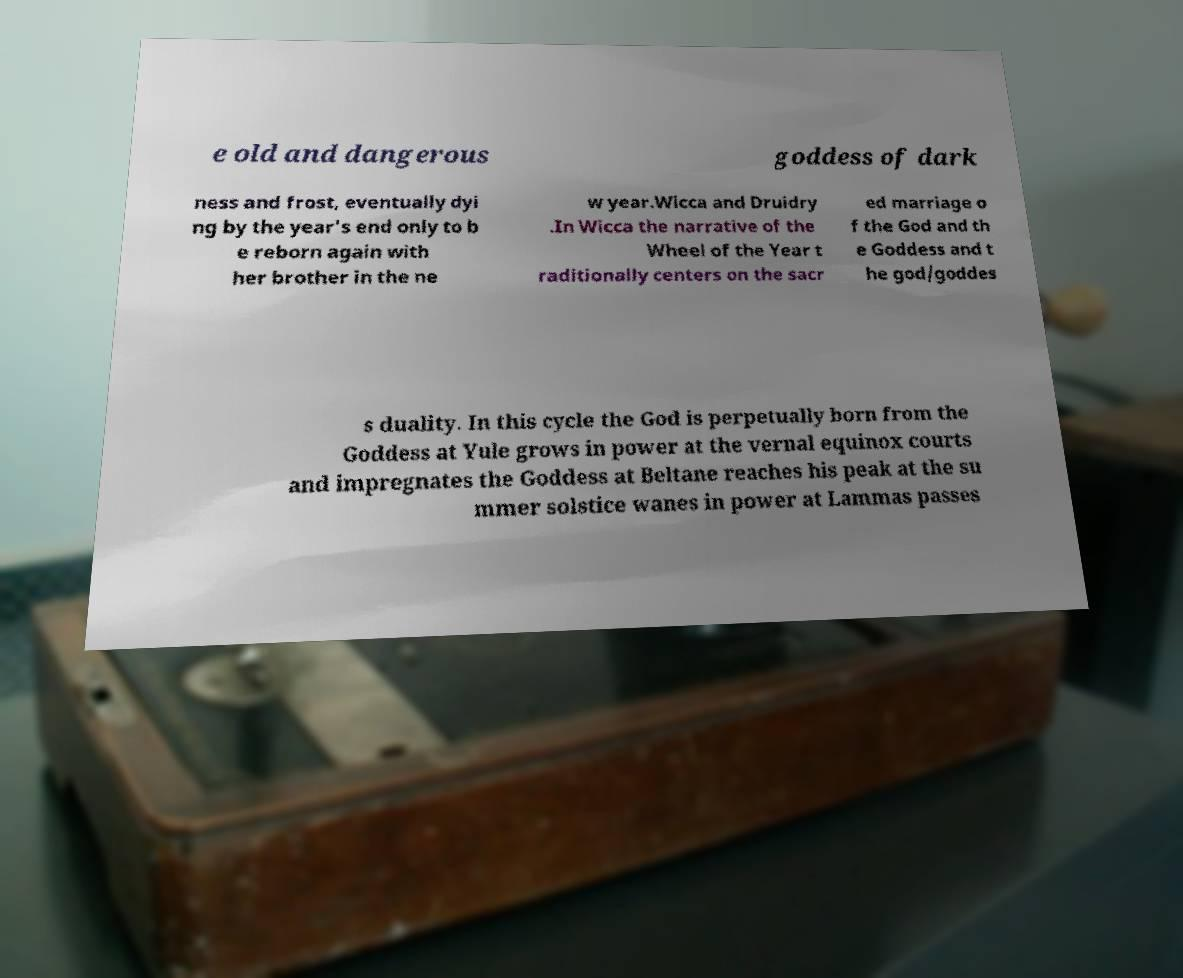Can you read and provide the text displayed in the image?This photo seems to have some interesting text. Can you extract and type it out for me? e old and dangerous goddess of dark ness and frost, eventually dyi ng by the year's end only to b e reborn again with her brother in the ne w year.Wicca and Druidry .In Wicca the narrative of the Wheel of the Year t raditionally centers on the sacr ed marriage o f the God and th e Goddess and t he god/goddes s duality. In this cycle the God is perpetually born from the Goddess at Yule grows in power at the vernal equinox courts and impregnates the Goddess at Beltane reaches his peak at the su mmer solstice wanes in power at Lammas passes 